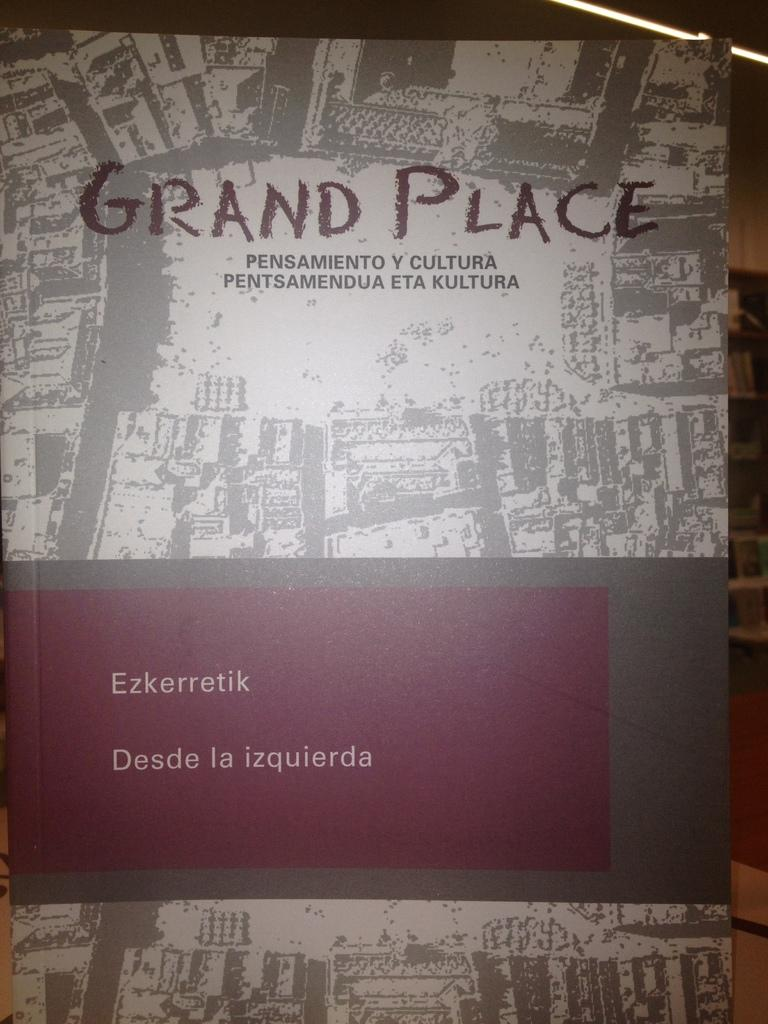Provide a one-sentence caption for the provided image. The book cover of Grand Place, which has a Spanish subtitle. 